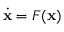<formula> <loc_0><loc_0><loc_500><loc_500>{ \dot { x } } = F ( x )</formula> 